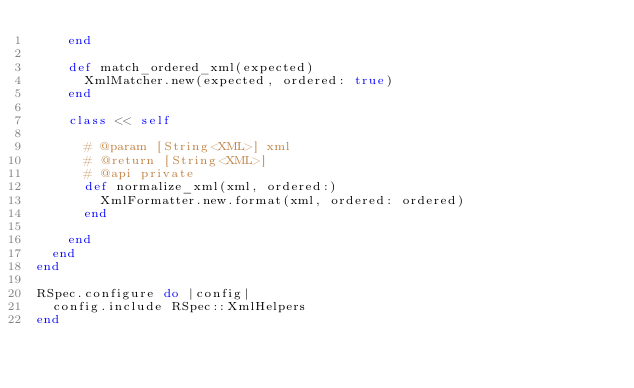<code> <loc_0><loc_0><loc_500><loc_500><_Ruby_>    end

    def match_ordered_xml(expected)
      XmlMatcher.new(expected, ordered: true)
    end

    class << self

      # @param [String<XML>] xml
      # @return [String<XML>]
      # @api private
      def normalize_xml(xml, ordered:)
        XmlFormatter.new.format(xml, ordered: ordered)
      end

    end
  end
end

RSpec.configure do |config|
  config.include RSpec::XmlHelpers
end
</code> 